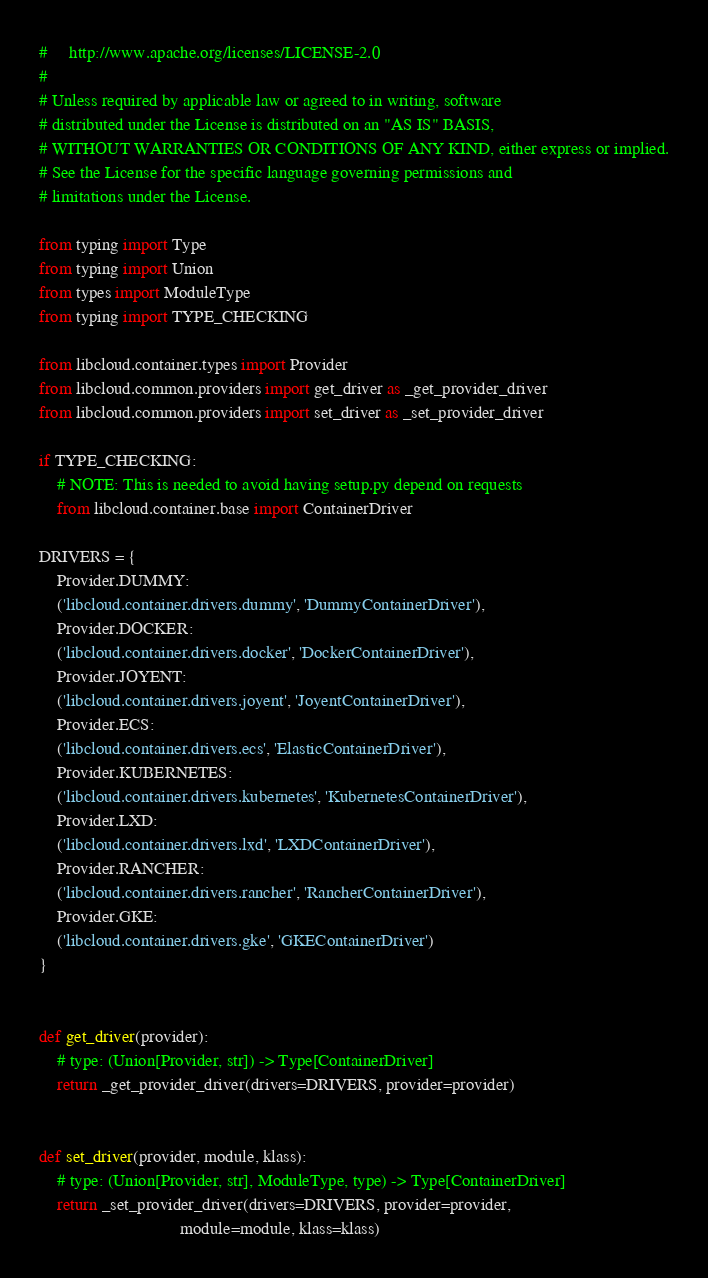Convert code to text. <code><loc_0><loc_0><loc_500><loc_500><_Python_>#     http://www.apache.org/licenses/LICENSE-2.0
#
# Unless required by applicable law or agreed to in writing, software
# distributed under the License is distributed on an "AS IS" BASIS,
# WITHOUT WARRANTIES OR CONDITIONS OF ANY KIND, either express or implied.
# See the License for the specific language governing permissions and
# limitations under the License.

from typing import Type
from typing import Union
from types import ModuleType
from typing import TYPE_CHECKING

from libcloud.container.types import Provider
from libcloud.common.providers import get_driver as _get_provider_driver
from libcloud.common.providers import set_driver as _set_provider_driver

if TYPE_CHECKING:
    # NOTE: This is needed to avoid having setup.py depend on requests
    from libcloud.container.base import ContainerDriver

DRIVERS = {
    Provider.DUMMY:
    ('libcloud.container.drivers.dummy', 'DummyContainerDriver'),
    Provider.DOCKER:
    ('libcloud.container.drivers.docker', 'DockerContainerDriver'),
    Provider.JOYENT:
    ('libcloud.container.drivers.joyent', 'JoyentContainerDriver'),
    Provider.ECS:
    ('libcloud.container.drivers.ecs', 'ElasticContainerDriver'),
    Provider.KUBERNETES:
    ('libcloud.container.drivers.kubernetes', 'KubernetesContainerDriver'),
    Provider.LXD:
    ('libcloud.container.drivers.lxd', 'LXDContainerDriver'),
    Provider.RANCHER:
    ('libcloud.container.drivers.rancher', 'RancherContainerDriver'),
    Provider.GKE:
    ('libcloud.container.drivers.gke', 'GKEContainerDriver')
}


def get_driver(provider):
    # type: (Union[Provider, str]) -> Type[ContainerDriver]
    return _get_provider_driver(drivers=DRIVERS, provider=provider)


def set_driver(provider, module, klass):
    # type: (Union[Provider, str], ModuleType, type) -> Type[ContainerDriver]
    return _set_provider_driver(drivers=DRIVERS, provider=provider,
                                module=module, klass=klass)
</code> 